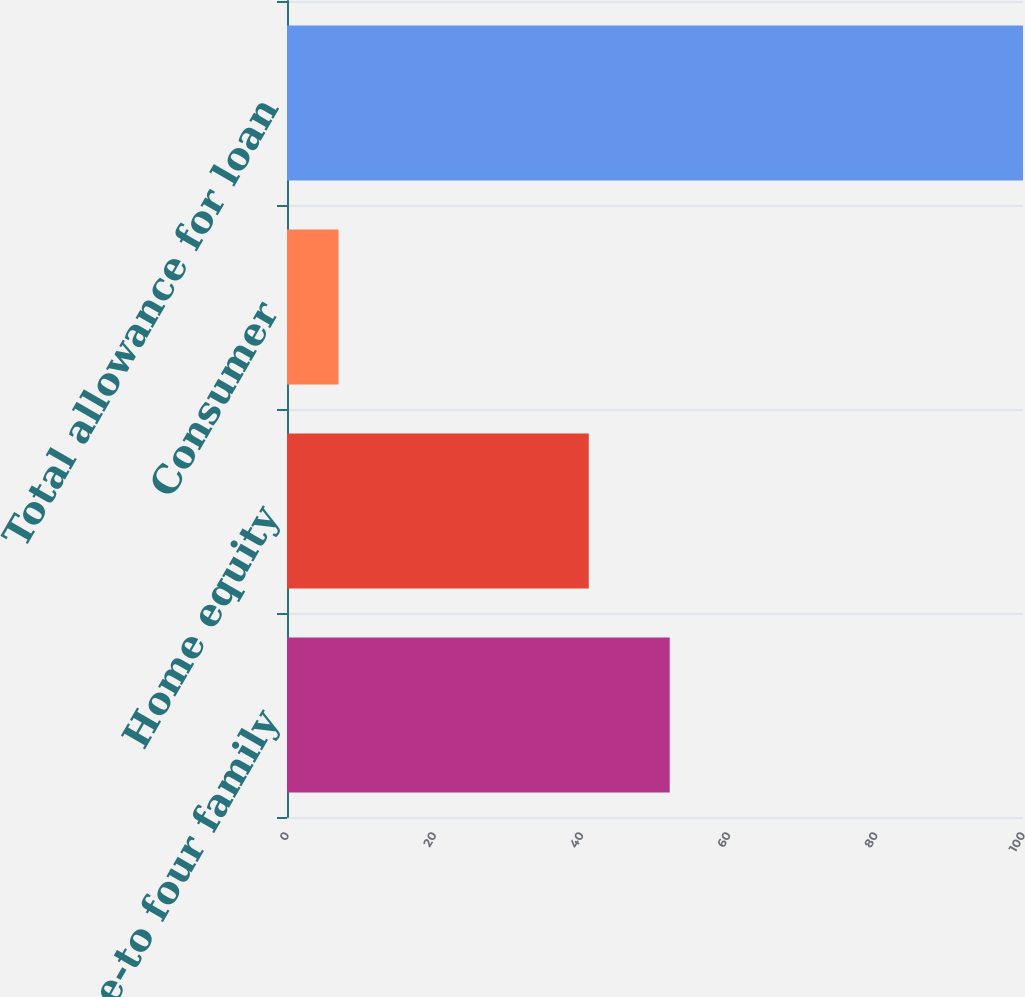Convert chart to OTSL. <chart><loc_0><loc_0><loc_500><loc_500><bar_chart><fcel>One-to four family<fcel>Home equity<fcel>Consumer<fcel>Total allowance for loan<nl><fcel>52<fcel>41<fcel>7<fcel>100<nl></chart> 